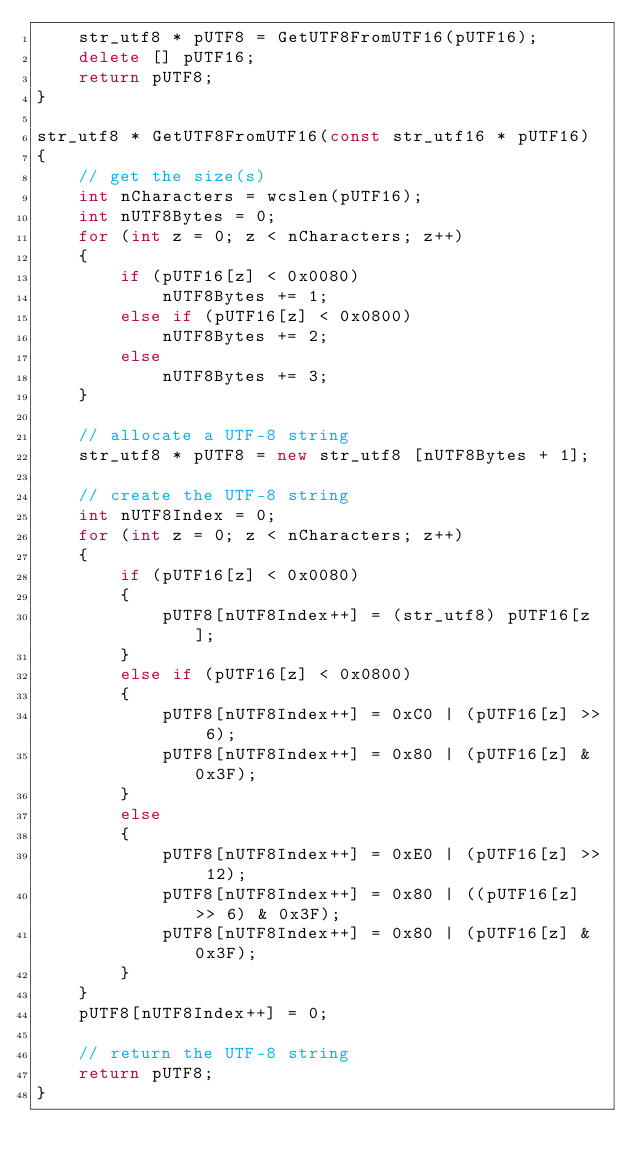<code> <loc_0><loc_0><loc_500><loc_500><_C++_>    str_utf8 * pUTF8 = GetUTF8FromUTF16(pUTF16);
    delete [] pUTF16;
    return pUTF8;
}

str_utf8 * GetUTF8FromUTF16(const str_utf16 * pUTF16)
{
    // get the size(s)
    int nCharacters = wcslen(pUTF16);
    int nUTF8Bytes = 0;
    for (int z = 0; z < nCharacters; z++)
    {
        if (pUTF16[z] < 0x0080)
            nUTF8Bytes += 1;
        else if (pUTF16[z] < 0x0800)
            nUTF8Bytes += 2;
        else
            nUTF8Bytes += 3;
    }

    // allocate a UTF-8 string
    str_utf8 * pUTF8 = new str_utf8 [nUTF8Bytes + 1];

    // create the UTF-8 string
    int nUTF8Index = 0;
    for (int z = 0; z < nCharacters; z++)
    {
        if (pUTF16[z] < 0x0080)
        {
            pUTF8[nUTF8Index++] = (str_utf8) pUTF16[z];
        }
        else if (pUTF16[z] < 0x0800)
        {
            pUTF8[nUTF8Index++] = 0xC0 | (pUTF16[z] >> 6);
            pUTF8[nUTF8Index++] = 0x80 | (pUTF16[z] & 0x3F);
        }
        else
        {
            pUTF8[nUTF8Index++] = 0xE0 | (pUTF16[z] >> 12);
            pUTF8[nUTF8Index++] = 0x80 | ((pUTF16[z] >> 6) & 0x3F);
            pUTF8[nUTF8Index++] = 0x80 | (pUTF16[z] & 0x3F);
        }
    }
    pUTF8[nUTF8Index++] = 0;

    // return the UTF-8 string
    return pUTF8;
}
</code> 